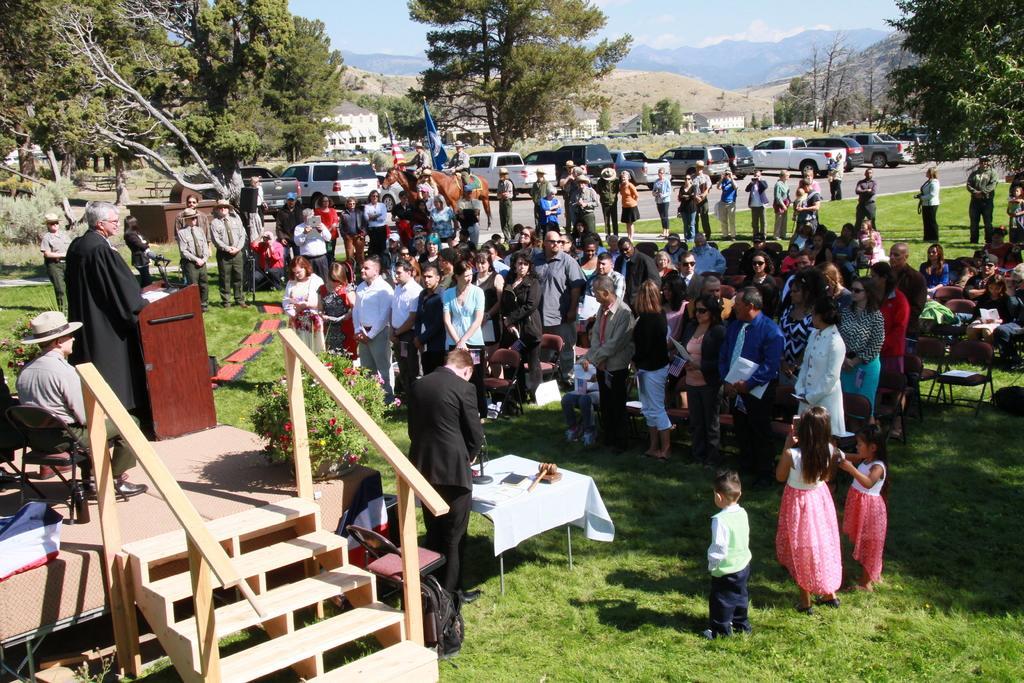Describe this image in one or two sentences. On the left side, there is a person in a black color coat, smiling and standing in front of a mic which is attached to a stand. This stand is on a stage, on which there are two persons sitting on chairs and there is a plant which is having flowers. Beside this stage, there are wooden steps, a chair and a person in a suit standing in front of a table, on which there are some objects. On the right side, there are persons. Some of them are sitting on chairs. In the background, there are vehicles parked on the road, there are trees, mountains and there are clouds in the sky. 